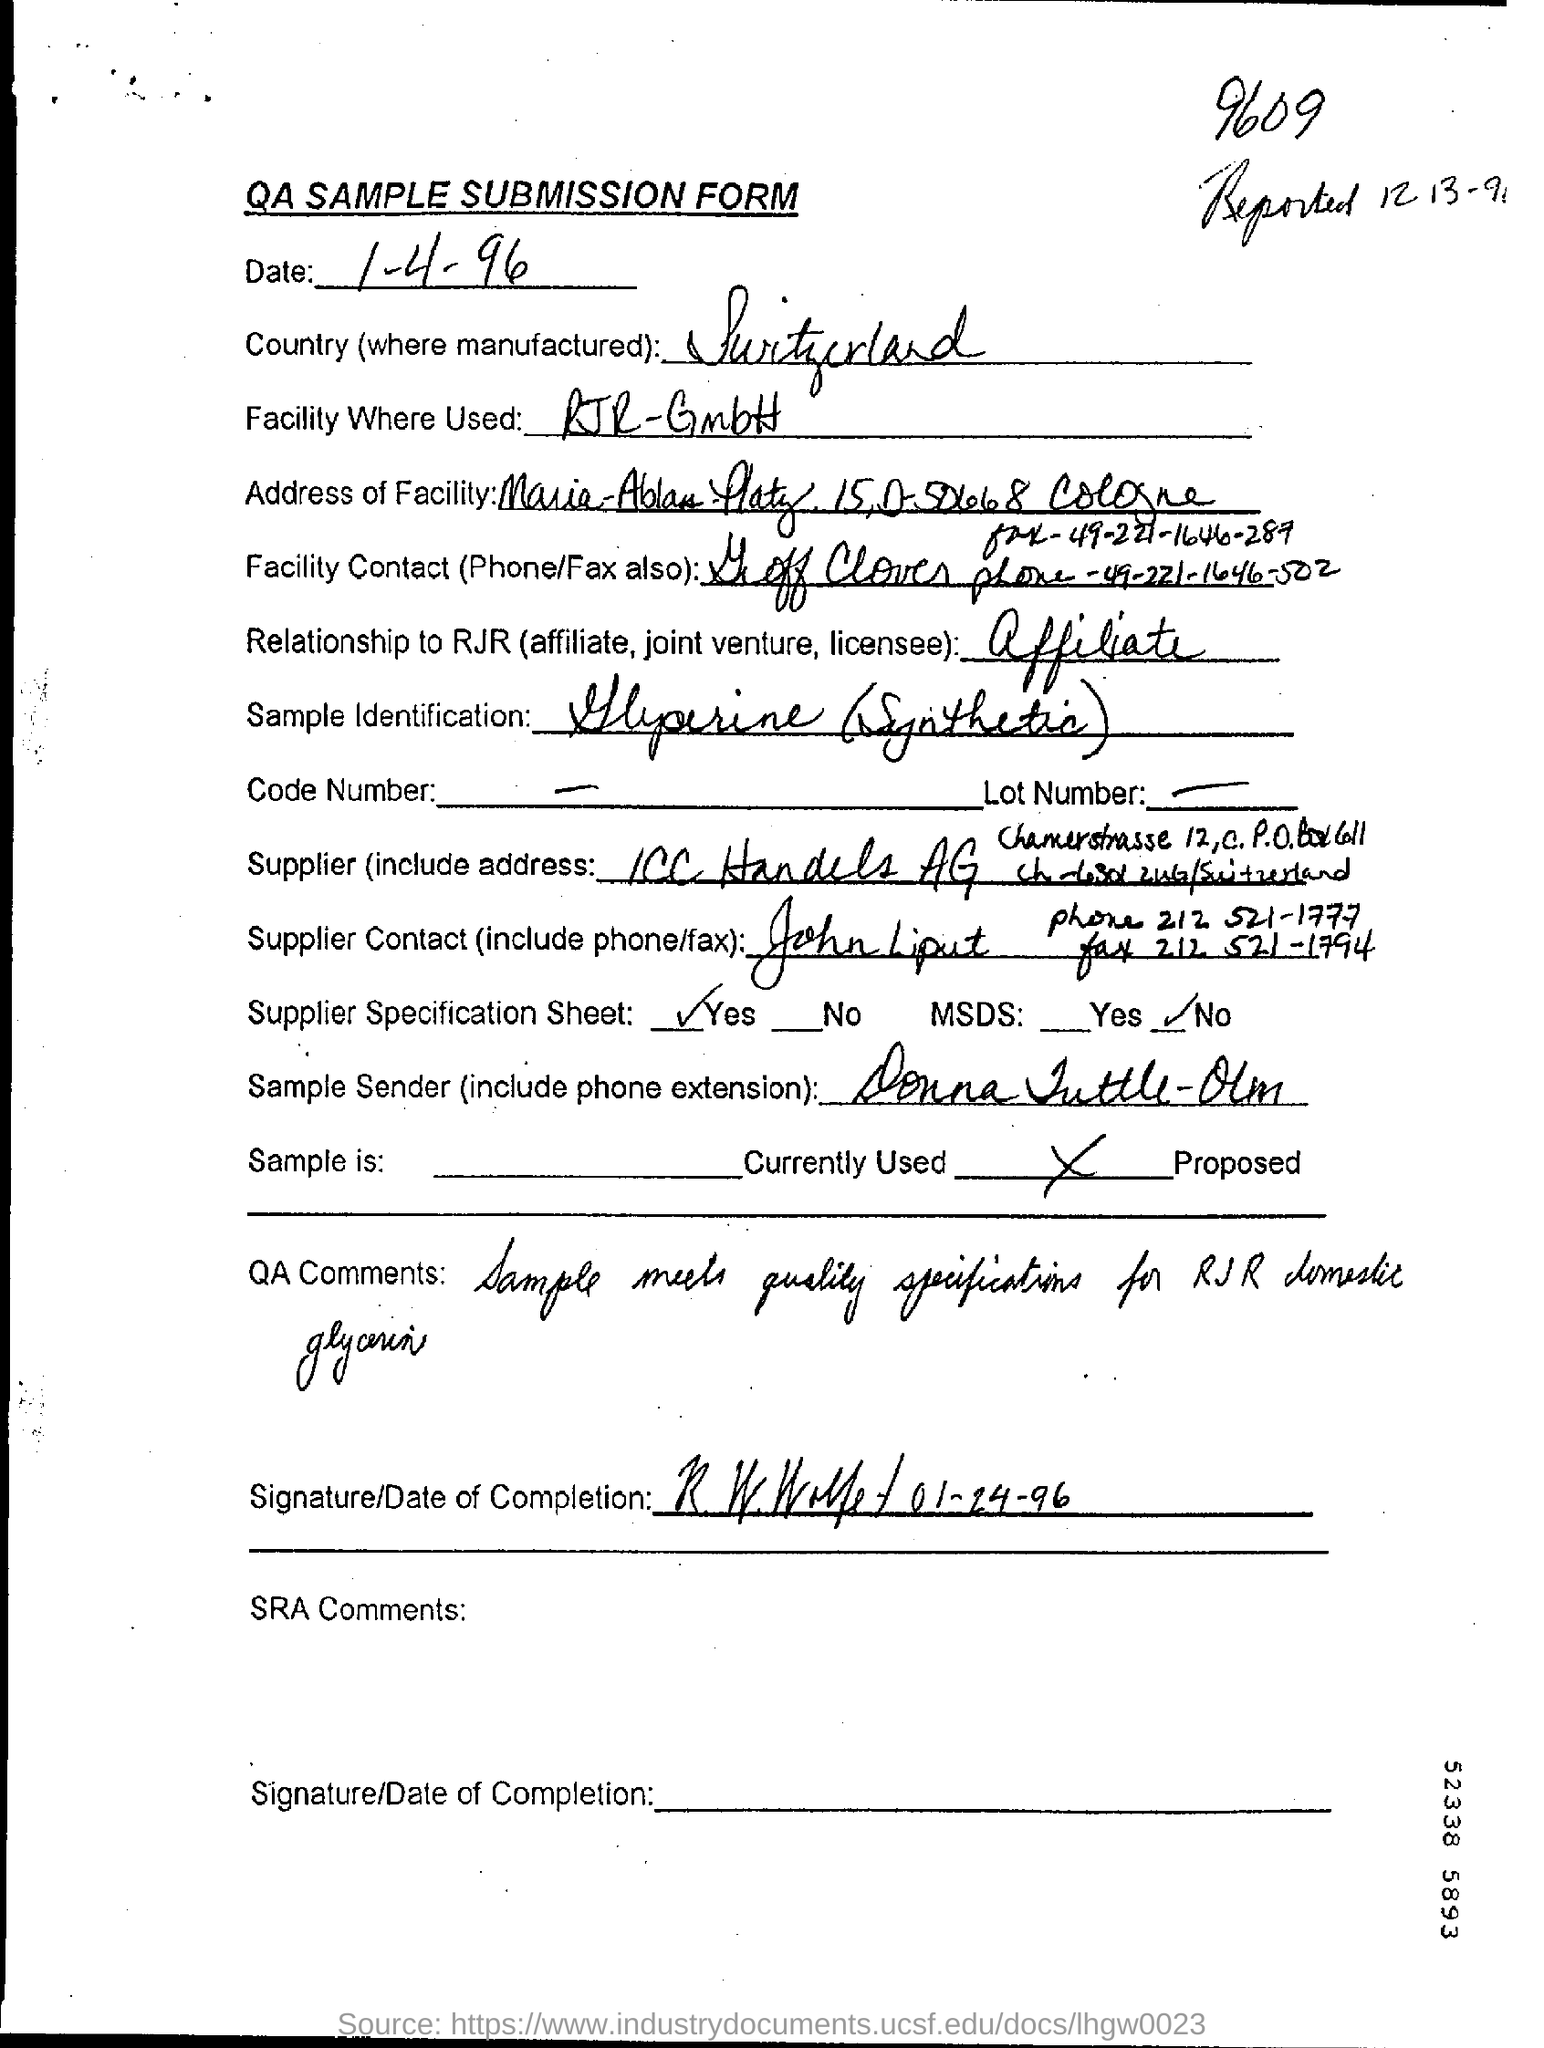What is the date mentioned?
Make the answer very short. 1-4-96. What is the name of the country mentioned?
Provide a short and direct response. Switzerland. What is the heading of the document?
Offer a terse response. QA SAMPLE SUBMISSION FORM. 